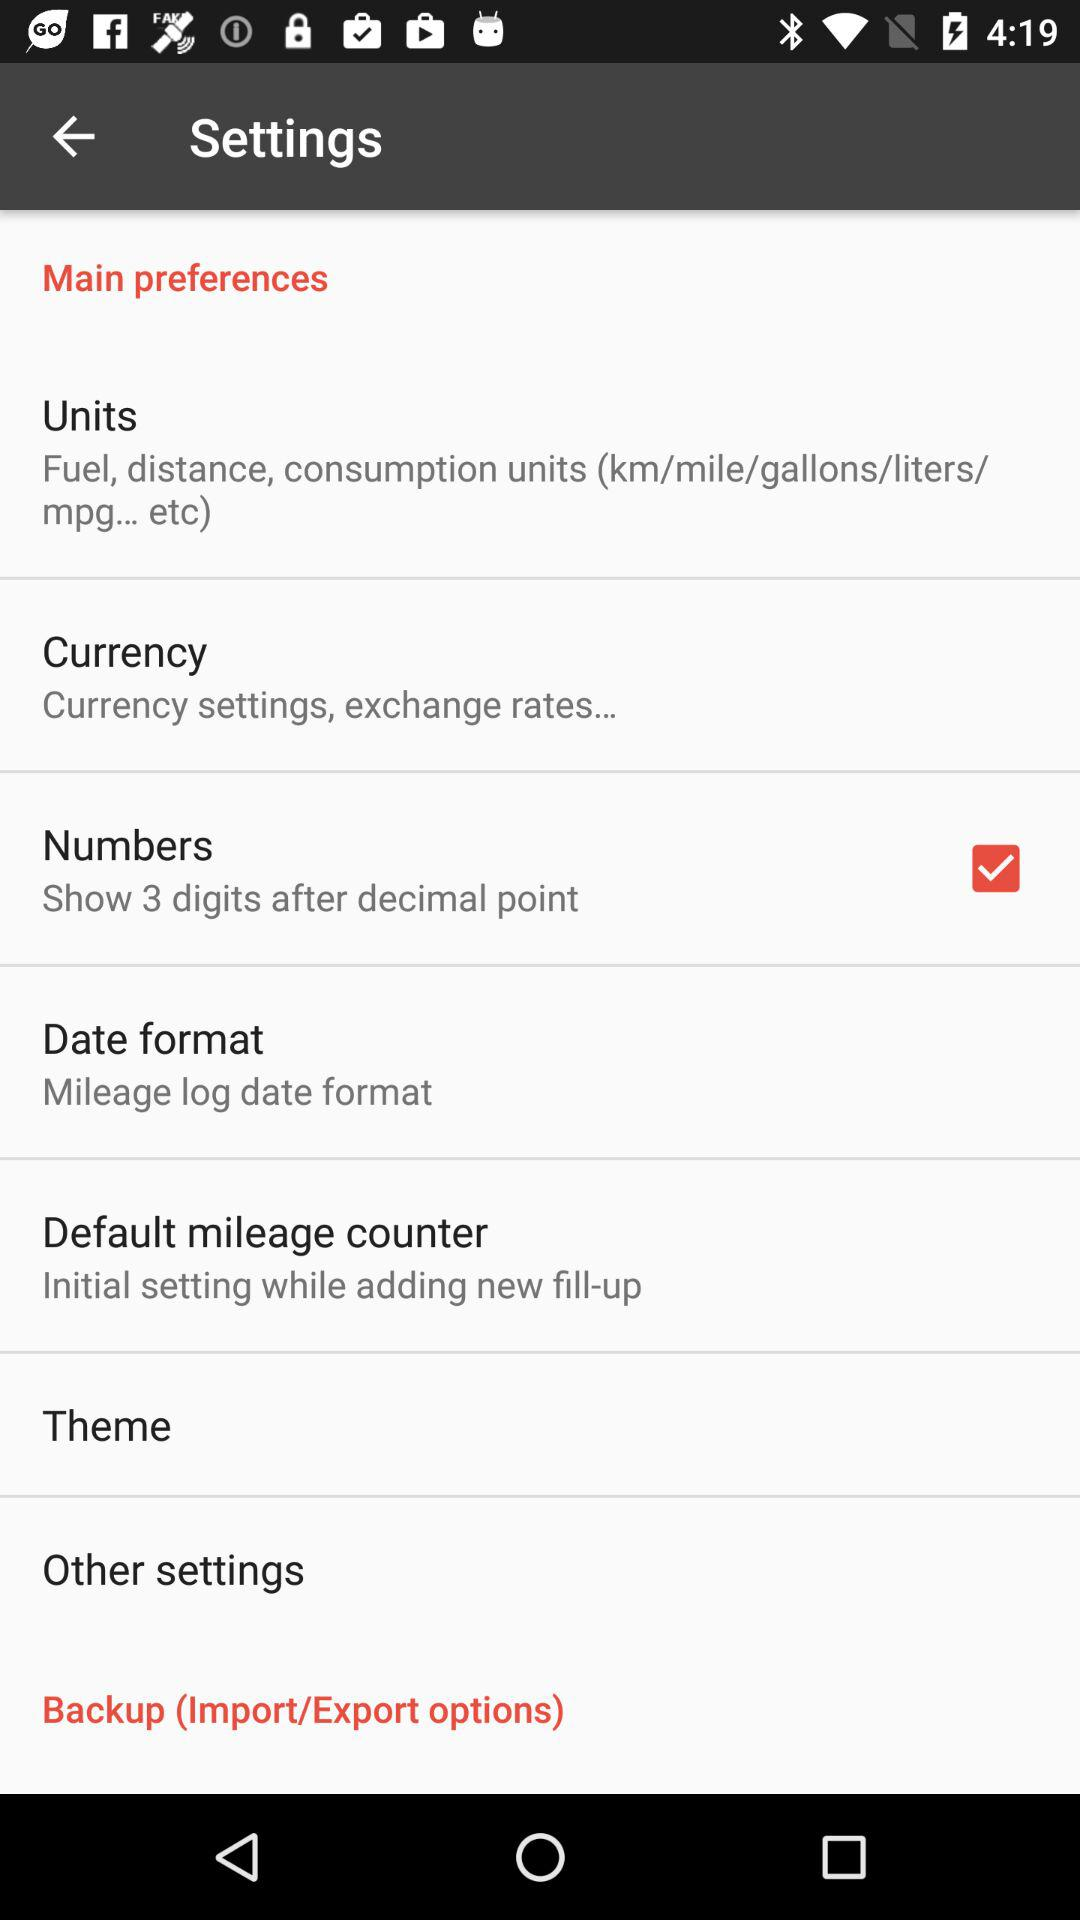What is the description of units? The description of units is "Fuel, distance, consumption units (km/mile/gallons/liters/ mpg... etc)". 